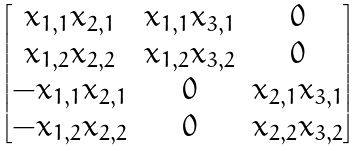Convert formula to latex. <formula><loc_0><loc_0><loc_500><loc_500>\begin{bmatrix} x _ { 1 , 1 } x _ { 2 , 1 } & x _ { 1 , 1 } x _ { 3 , 1 } & 0 \\ x _ { 1 , 2 } x _ { 2 , 2 } & x _ { 1 , 2 } x _ { 3 , 2 } & 0 \\ - x _ { 1 , 1 } x _ { 2 , 1 } & 0 & x _ { 2 , 1 } x _ { 3 , 1 } \\ - x _ { 1 , 2 } x _ { 2 , 2 } & 0 & x _ { 2 , 2 } x _ { 3 , 2 } \end{bmatrix}</formula> 